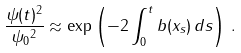Convert formula to latex. <formula><loc_0><loc_0><loc_500><loc_500>\frac { \| \psi ( t ) \| ^ { 2 } } { \| \psi _ { 0 } \| ^ { 2 } } \approx \exp \left ( - 2 \int _ { 0 } ^ { t } b ( x _ { s } ) \, d s \right ) \, .</formula> 